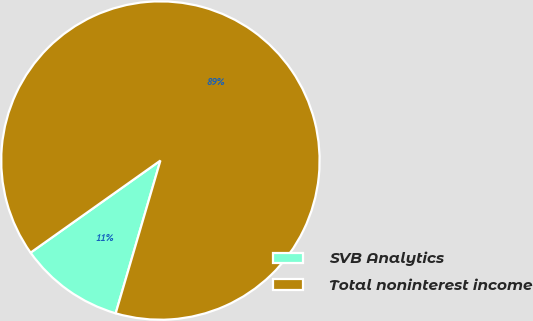Convert chart. <chart><loc_0><loc_0><loc_500><loc_500><pie_chart><fcel>SVB Analytics<fcel>Total noninterest income<nl><fcel>10.65%<fcel>89.35%<nl></chart> 